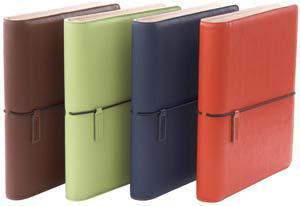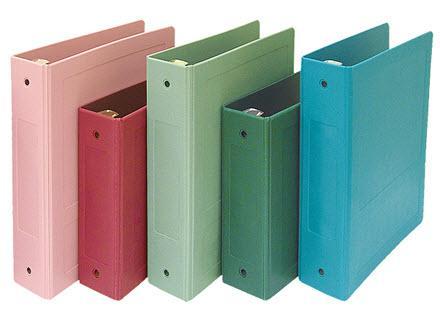The first image is the image on the left, the second image is the image on the right. Considering the images on both sides, is "There are exactly nine binders in the pair of images." valid? Answer yes or no. Yes. The first image is the image on the left, the second image is the image on the right. Considering the images on both sides, is "Here, we see a total of nine binders." valid? Answer yes or no. Yes. 